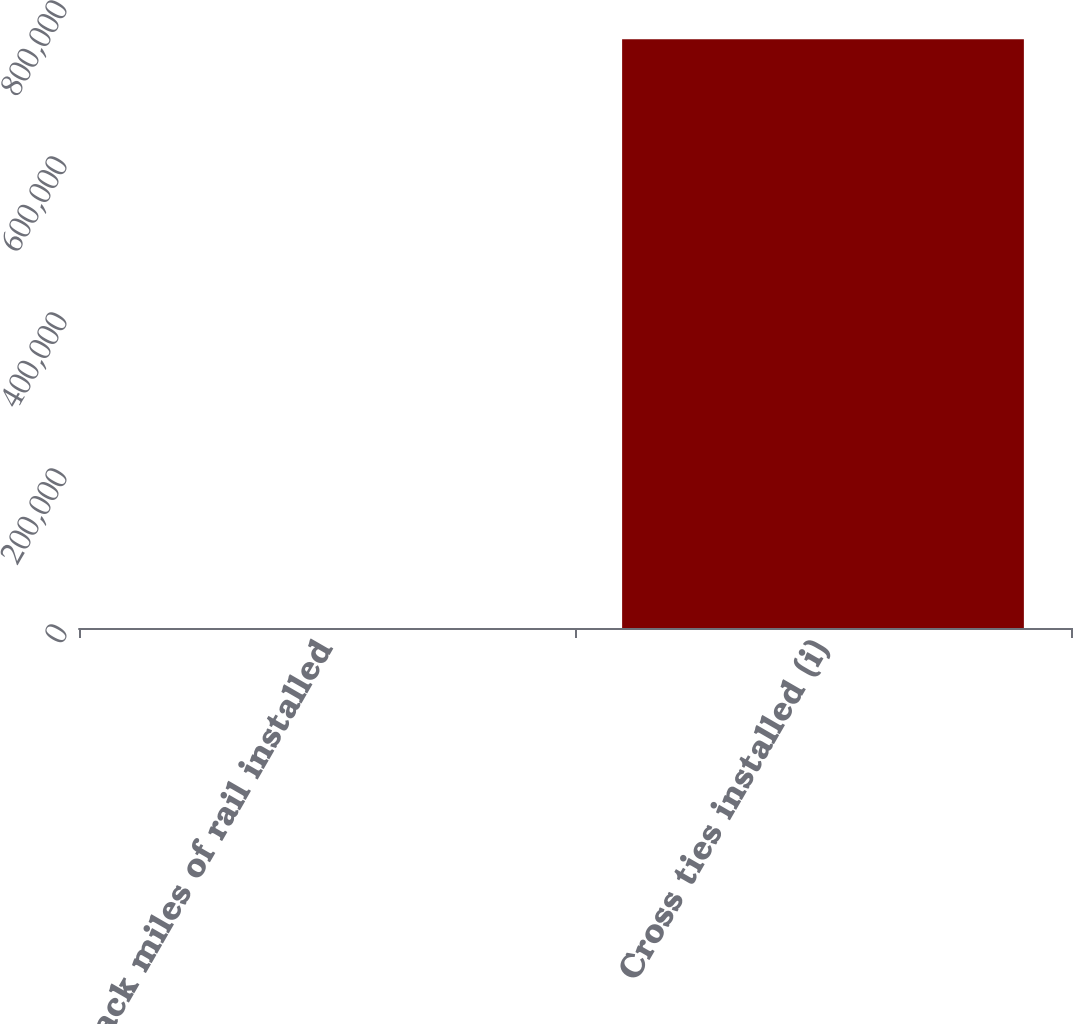<chart> <loc_0><loc_0><loc_500><loc_500><bar_chart><fcel>Track miles of rail installed<fcel>Cross ties installed (i)<nl><fcel>49<fcel>754900<nl></chart> 